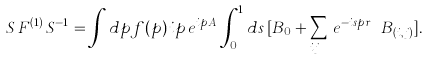<formula> <loc_0><loc_0><loc_500><loc_500>S \, F ^ { ( 1 ) } \, S ^ { - 1 } = \int d p f ( p ) \, i p \, e ^ { i p A } \, \int _ { 0 } ^ { 1 } d s \, [ B _ { 0 } + \sum _ { i \neq j } \, e ^ { - i s p r _ { i j } } \, B _ { ( i , j ) } ] .</formula> 